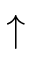<formula> <loc_0><loc_0><loc_500><loc_500>\uparrow</formula> 